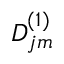Convert formula to latex. <formula><loc_0><loc_0><loc_500><loc_500>D _ { j m } ^ { ( 1 ) }</formula> 